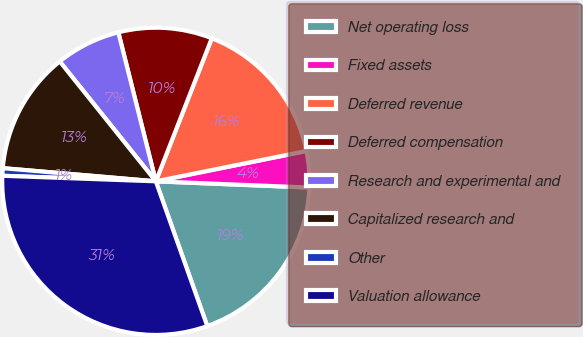Convert chart. <chart><loc_0><loc_0><loc_500><loc_500><pie_chart><fcel>Net operating loss<fcel>Fixed assets<fcel>Deferred revenue<fcel>Deferred compensation<fcel>Research and experimental and<fcel>Capitalized research and<fcel>Other<fcel>Valuation allowance<nl><fcel>18.92%<fcel>3.81%<fcel>15.9%<fcel>9.86%<fcel>6.83%<fcel>12.88%<fcel>0.79%<fcel>31.01%<nl></chart> 